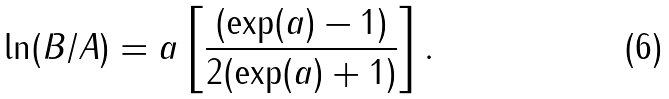Convert formula to latex. <formula><loc_0><loc_0><loc_500><loc_500>\ln ( B / A ) = a \left [ \frac { ( \exp ( a ) - 1 ) } { 2 ( \exp ( a ) + 1 ) } \right ] .</formula> 